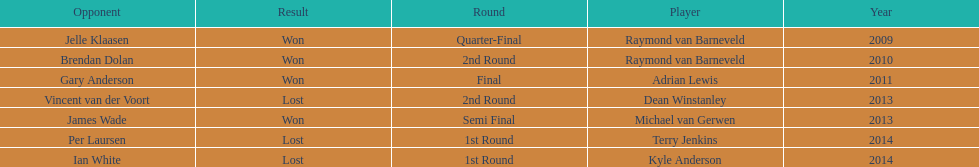Did terry jenkins or per laursen win in 2014? Per Laursen. 